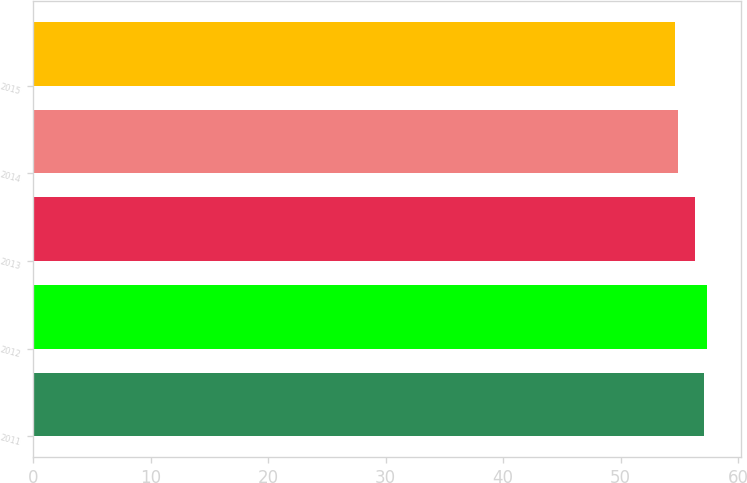Convert chart to OTSL. <chart><loc_0><loc_0><loc_500><loc_500><bar_chart><fcel>2011<fcel>2012<fcel>2013<fcel>2014<fcel>2015<nl><fcel>57.1<fcel>57.35<fcel>56.3<fcel>54.9<fcel>54.6<nl></chart> 